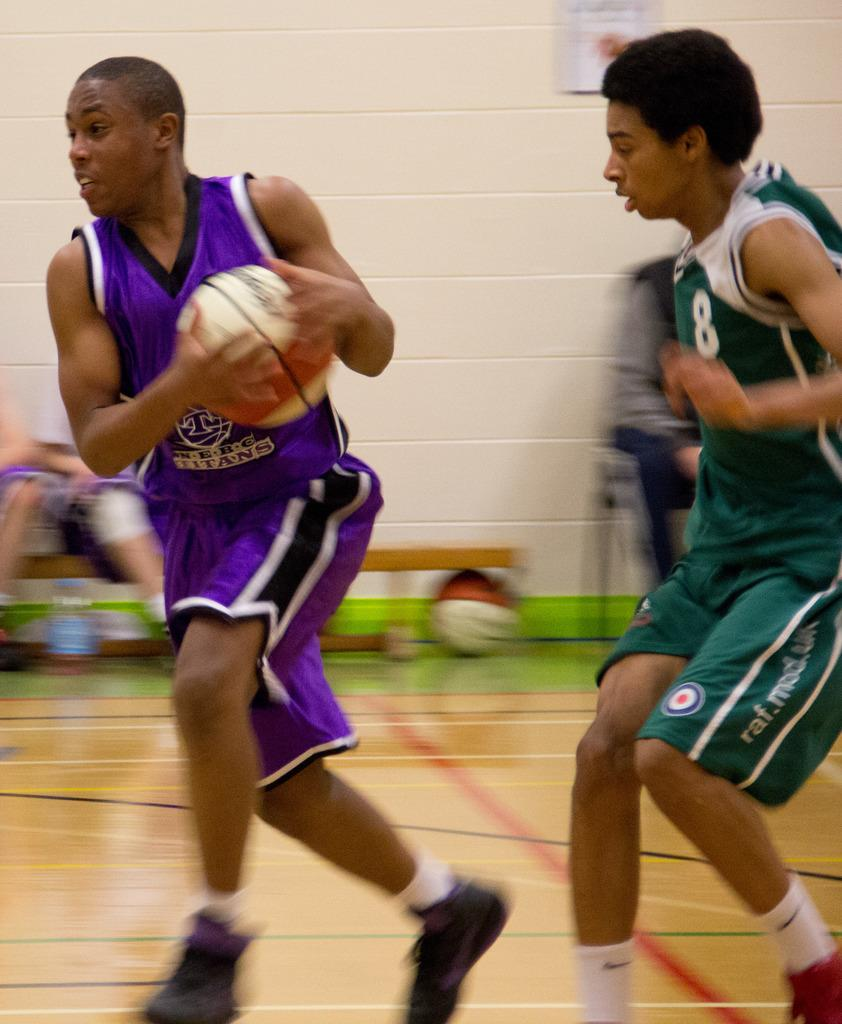<image>
Give a short and clear explanation of the subsequent image. A man wearing a Titans jersey plays against number 8 in the green clothing. 